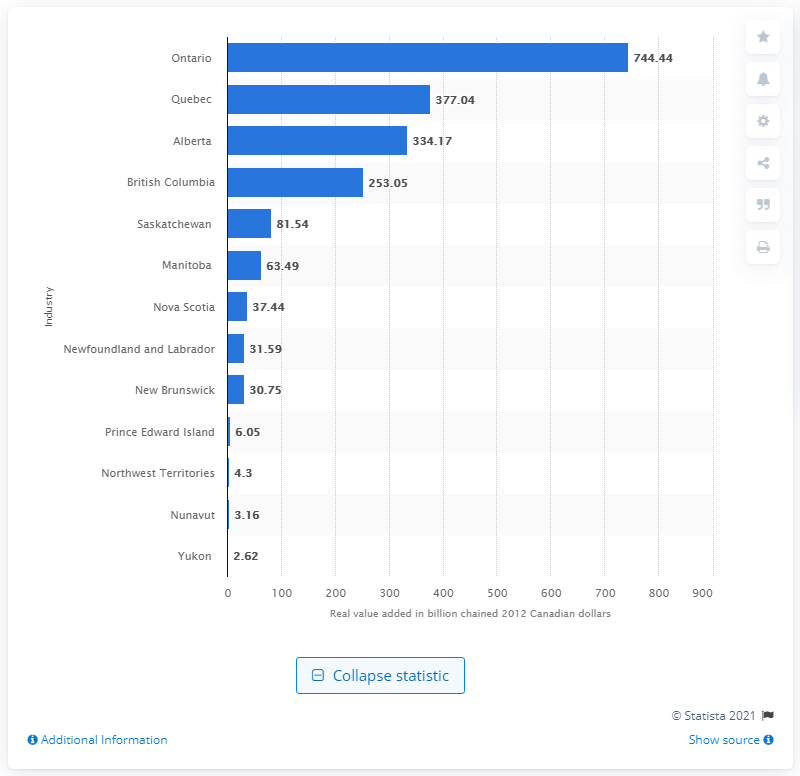Give some essential details in this illustration. In 2012, the province of Ontario contributed 744.44 billion Canadian dollars to the country's Gross Domestic Product (GDP). 